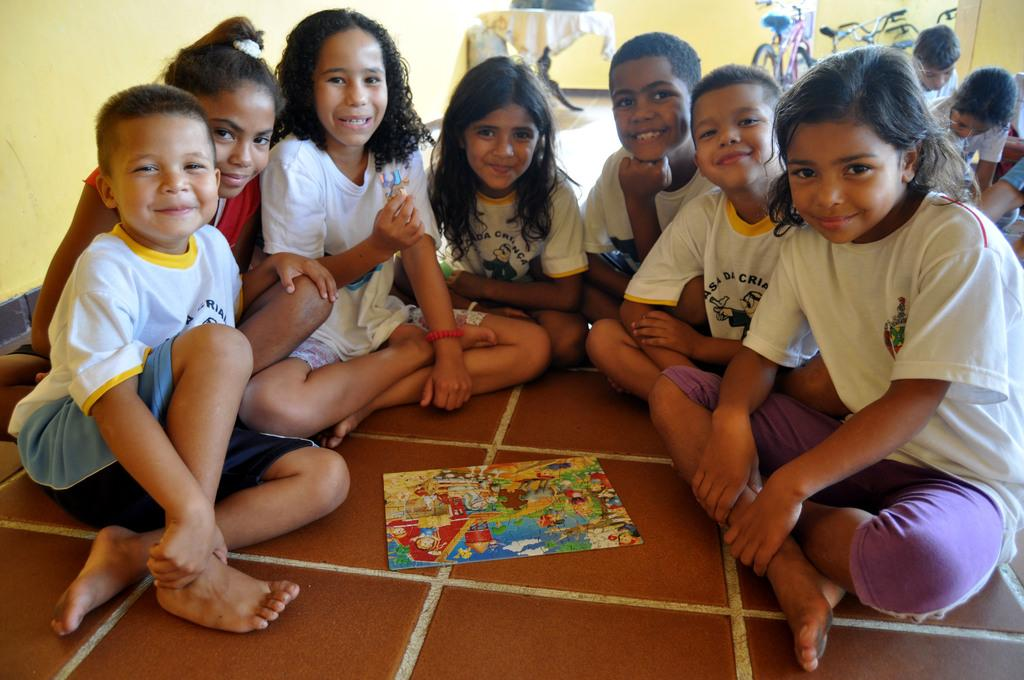What are the people in the image doing? The persons in the image are sitting on the ground. What can be seen in the background of the image? There is a wall, a table, a clock, and bicycles in the background of the image. What type of bath is the father taking in the image? There is no father or bath present in the image. What impulse might have caused the persons to sit on the ground in the image? The image does not provide information about the reasons or impulses behind the persons sitting on the ground. 